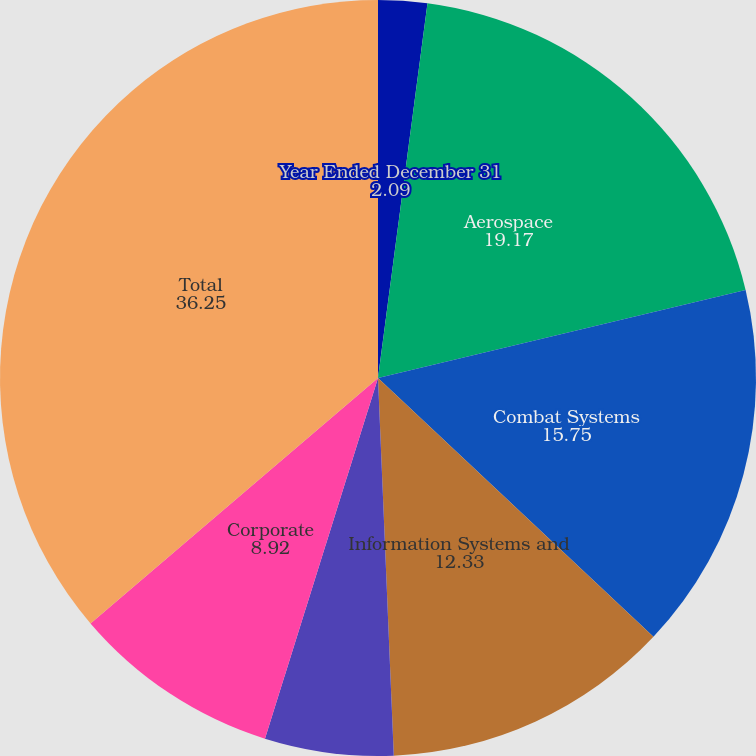<chart> <loc_0><loc_0><loc_500><loc_500><pie_chart><fcel>Year Ended December 31<fcel>Aerospace<fcel>Combat Systems<fcel>Information Systems and<fcel>Marine Systems<fcel>Corporate<fcel>Total<nl><fcel>2.09%<fcel>19.17%<fcel>15.75%<fcel>12.33%<fcel>5.5%<fcel>8.92%<fcel>36.25%<nl></chart> 